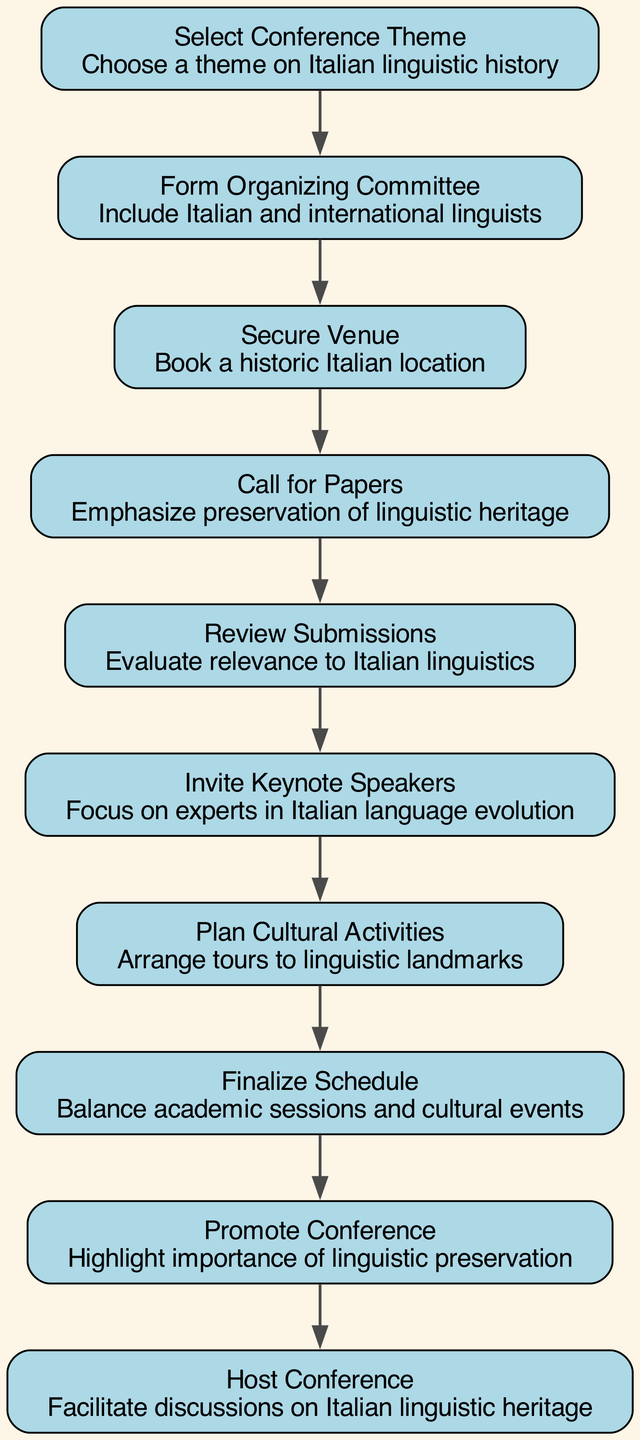What is the first step in organizing the conference? The diagram shows that the first step is "Select Conference Theme." This is the topmost node in the flowchart, indicating it is the initial action to be taken.
Answer: Select Conference Theme How many total steps are there in the diagram? By counting the nodes in the flowchart, we see there are ten distinct steps listed, each representing a part of the conference organization process.
Answer: Ten What step follows after "Review Submissions"? The diagram indicates that "Invite Keynote Speakers" comes directly after "Review Submissions," showing the flow of actions in organizing the conference.
Answer: Invite Keynote Speakers Which step involves cultural activities? The step "Plan Cultural Activities" specifically mentions arranging tours to linguistic landmarks, indicating its focus on cultural aspects related to the conference.
Answer: Plan Cultural Activities What is the main focus during the "Call for Papers"? The details provided for the "Call for Papers" state that it emphasizes "preservation of linguistic heritage," which highlights the significance during this step.
Answer: Preservation of linguistic heritage Explain the relationship between "Promote Conference" and "Host Conference." "Promote Conference" precedes "Host Conference" in the flowchart, suggesting that promotion is essential before hosting to ensure awareness and attendance at the event. This sequential relationship emphasizes preparation and outreach as vital components of the conference planning process.
Answer: Promote Conference precedes Host Conference What is the theme for the conference related to? The theme, specified in the first step as "Choose a theme on Italian linguistic history," clearly relates to the subject matter and focus of the upcoming conference, centering on historical linguistics in Italy.
Answer: Italian linguistic history Where does the organizing committee get its members from? The step "Form Organizing Committee" states that the members should be "Include Italian and international linguists," indicating the diversity and inclusiveness of the committee's composition.
Answer: Include Italian and international linguists 